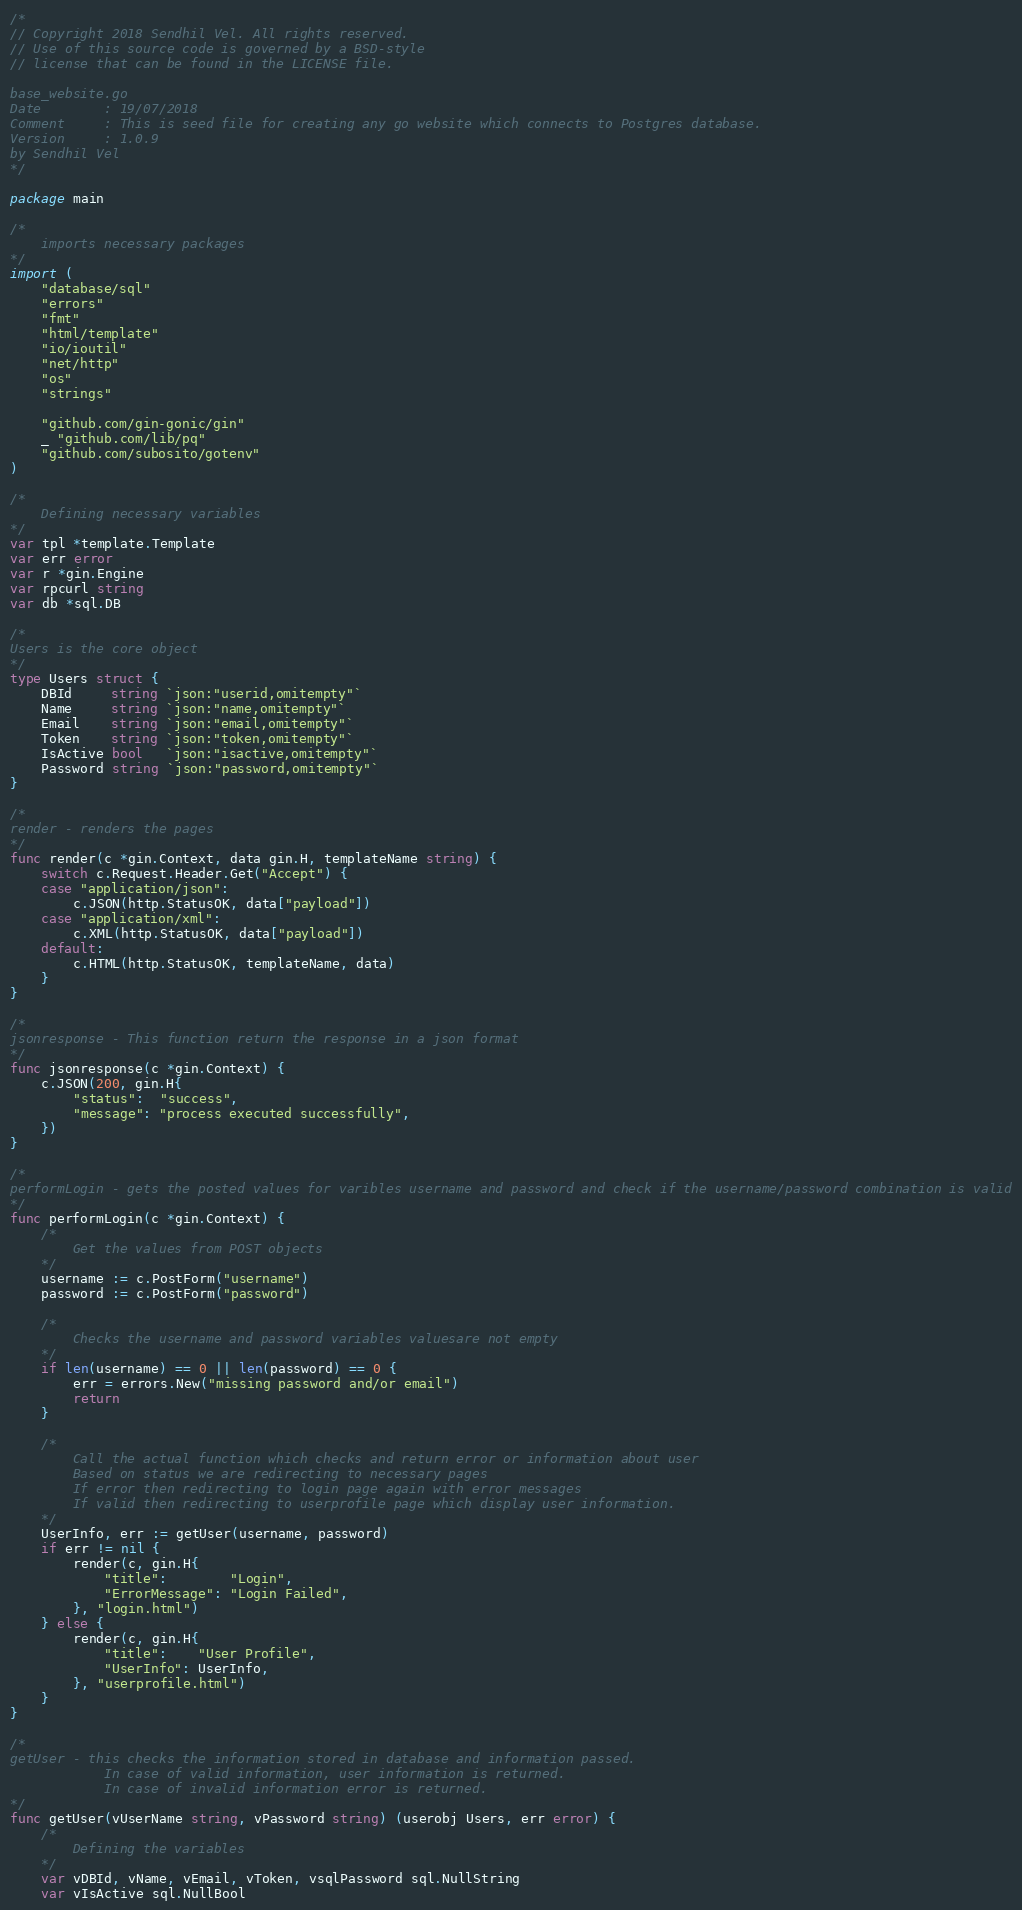Convert code to text. <code><loc_0><loc_0><loc_500><loc_500><_Go_>/*
// Copyright 2018 Sendhil Vel. All rights reserved.
// Use of this source code is governed by a BSD-style
// license that can be found in the LICENSE file.

base_website.go
Date 		: 19/07/2018
Comment 	: This is seed file for creating any go website which connects to Postgres database.
Version 	: 1.0.9
by Sendhil Vel
*/

package main

/*
	imports necessary packages
*/
import (
	"database/sql"
	"errors"
	"fmt"
	"html/template"
	"io/ioutil"
	"net/http"
	"os"
	"strings"

	"github.com/gin-gonic/gin"
	_ "github.com/lib/pq"
	"github.com/subosito/gotenv"
)

/*
	Defining necessary variables
*/
var tpl *template.Template
var err error
var r *gin.Engine
var rpcurl string
var db *sql.DB

/*
Users is the core object
*/
type Users struct {
	DBId     string `json:"userid,omitempty"`
	Name     string `json:"name,omitempty"`
	Email    string `json:"email,omitempty"`
	Token    string `json:"token,omitempty"`
	IsActive bool   `json:"isactive,omitempty"`
	Password string `json:"password,omitempty"`
}

/*
render - renders the pages
*/
func render(c *gin.Context, data gin.H, templateName string) {
	switch c.Request.Header.Get("Accept") {
	case "application/json":
		c.JSON(http.StatusOK, data["payload"])
	case "application/xml":
		c.XML(http.StatusOK, data["payload"])
	default:
		c.HTML(http.StatusOK, templateName, data)
	}
}

/*
jsonresponse - This function return the response in a json format
*/
func jsonresponse(c *gin.Context) {
	c.JSON(200, gin.H{
		"status":  "success",
		"message": "process executed successfully",
	})
}

/*
performLogin - gets the posted values for varibles username and password and check if the username/password combination is valid
*/
func performLogin(c *gin.Context) {
	/*
		Get the values from POST objects
	*/
	username := c.PostForm("username")
	password := c.PostForm("password")

	/*
		Checks the username and password variables valuesare not empty
	*/
	if len(username) == 0 || len(password) == 0 {
		err = errors.New("missing password and/or email")
		return
	}

	/*
		Call the actual function which checks and return error or information about user
		Based on status we are redirecting to necessary pages
		If error then redirecting to login page again with error messages
		If valid then redirecting to userprofile page which display user information.
	*/
	UserInfo, err := getUser(username, password)
	if err != nil {
		render(c, gin.H{
			"title":        "Login",
			"ErrorMessage": "Login Failed",
		}, "login.html")
	} else {
		render(c, gin.H{
			"title":    "User Profile",
			"UserInfo": UserInfo,
		}, "userprofile.html")
	}
}

/*
getUser - this checks the information stored in database and information passed.
			In case of valid information, user information is returned.
			In case of invalid information error is returned.
*/
func getUser(vUserName string, vPassword string) (userobj Users, err error) {
	/*
		Defining the variables
	*/
	var vDBId, vName, vEmail, vToken, vsqlPassword sql.NullString
	var vIsActive sql.NullBool
</code> 